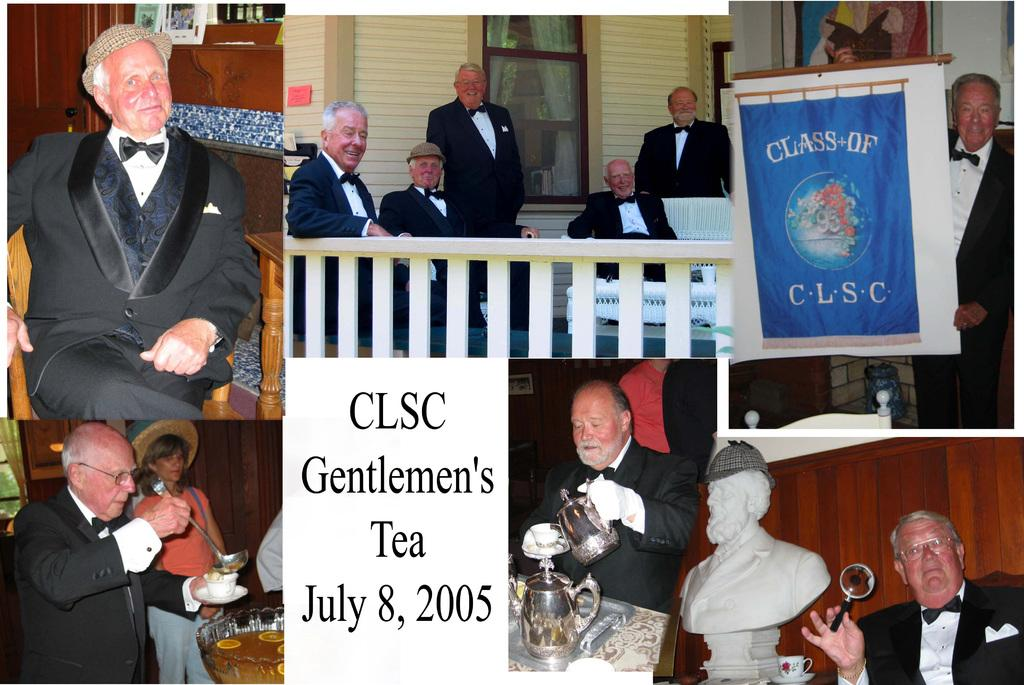How many people are in the image? There is a group of people in the image, but the exact number is not specified. What else can be seen in the image besides the group of people? There is a statue, a poster, and a fence in the image. How many rabbits are hiding behind the statue in the image? There are no rabbits present in the image; only the group of people, statue, poster, and fence can be seen. 